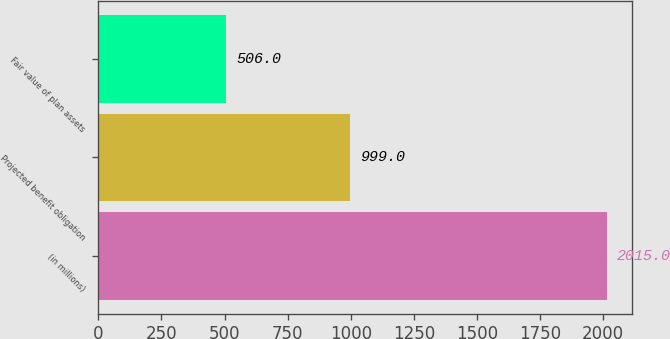Convert chart. <chart><loc_0><loc_0><loc_500><loc_500><bar_chart><fcel>(in millions)<fcel>Projected benefit obligation<fcel>Fair value of plan assets<nl><fcel>2015<fcel>999<fcel>506<nl></chart> 